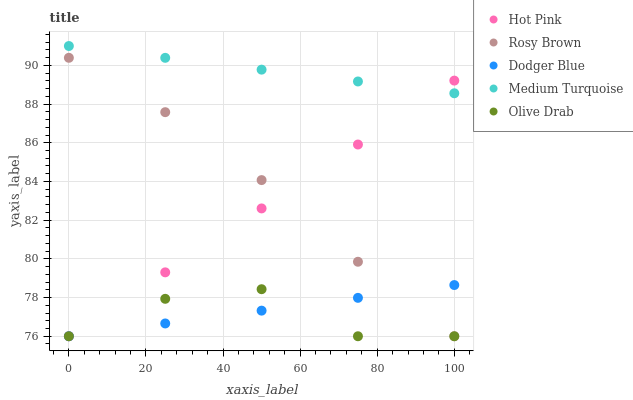Does Olive Drab have the minimum area under the curve?
Answer yes or no. Yes. Does Medium Turquoise have the maximum area under the curve?
Answer yes or no. Yes. Does Hot Pink have the minimum area under the curve?
Answer yes or no. No. Does Hot Pink have the maximum area under the curve?
Answer yes or no. No. Is Dodger Blue the smoothest?
Answer yes or no. Yes. Is Olive Drab the roughest?
Answer yes or no. Yes. Is Hot Pink the smoothest?
Answer yes or no. No. Is Hot Pink the roughest?
Answer yes or no. No. Does Rosy Brown have the lowest value?
Answer yes or no. Yes. Does Medium Turquoise have the lowest value?
Answer yes or no. No. Does Medium Turquoise have the highest value?
Answer yes or no. Yes. Does Hot Pink have the highest value?
Answer yes or no. No. Is Dodger Blue less than Medium Turquoise?
Answer yes or no. Yes. Is Medium Turquoise greater than Olive Drab?
Answer yes or no. Yes. Does Hot Pink intersect Olive Drab?
Answer yes or no. Yes. Is Hot Pink less than Olive Drab?
Answer yes or no. No. Is Hot Pink greater than Olive Drab?
Answer yes or no. No. Does Dodger Blue intersect Medium Turquoise?
Answer yes or no. No. 